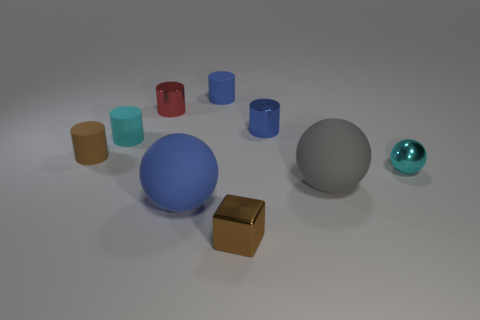How many large spheres are there?
Keep it short and to the point. 2. Are the large gray object and the brown cylinder left of the blue sphere made of the same material?
Keep it short and to the point. Yes. How many other tiny metallic cubes are the same color as the cube?
Offer a very short reply. 0. What is the size of the gray thing?
Keep it short and to the point. Large. Do the large blue object and the rubber object that is on the right side of the small shiny cube have the same shape?
Keep it short and to the point. Yes. What color is the large thing that is made of the same material as the big gray sphere?
Ensure brevity in your answer.  Blue. There is a shiny cylinder left of the large blue matte object; what size is it?
Keep it short and to the point. Small. Is the number of big blue balls behind the big blue object less than the number of blue metallic balls?
Your answer should be compact. No. Is there any other thing that is the same shape as the brown metallic object?
Offer a very short reply. No. Are there fewer brown matte balls than blue metallic cylinders?
Make the answer very short. Yes. 